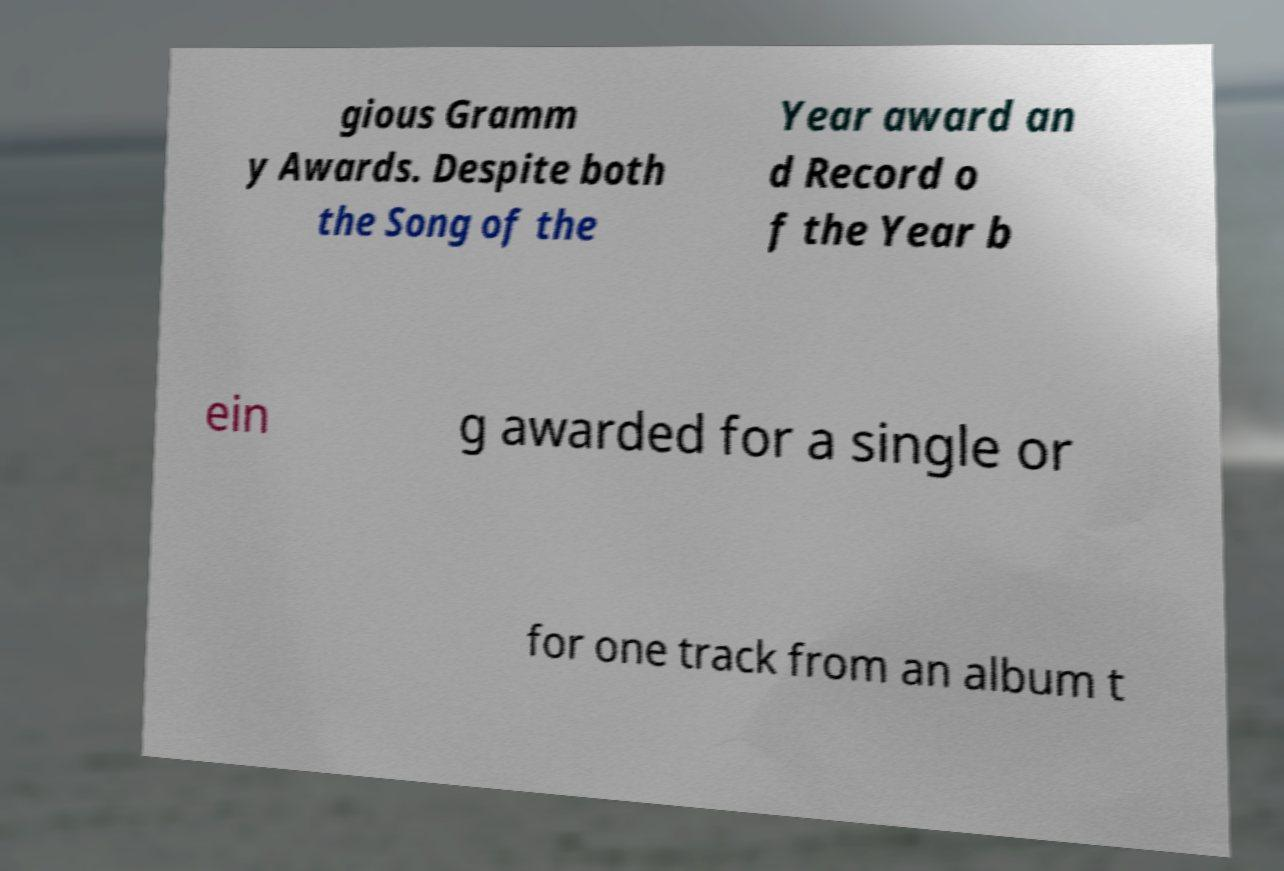Could you extract and type out the text from this image? gious Gramm y Awards. Despite both the Song of the Year award an d Record o f the Year b ein g awarded for a single or for one track from an album t 